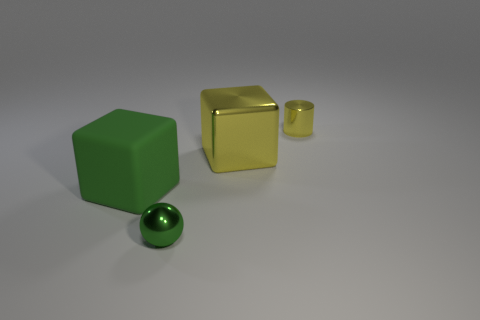Are there the same number of green objects that are to the left of the small green ball and tiny yellow metal things?
Offer a very short reply. Yes. There is a metal thing that is the same size as the ball; what is its shape?
Give a very brief answer. Cylinder. What number of other objects are there of the same shape as the green rubber thing?
Your answer should be very brief. 1. There is a yellow cylinder; is it the same size as the block to the right of the small ball?
Ensure brevity in your answer.  No. What number of objects are small objects that are in front of the large matte thing or tiny green balls?
Your answer should be compact. 1. What is the shape of the small thing in front of the yellow cube?
Offer a very short reply. Sphere. Is the number of tiny green metal spheres that are on the left side of the rubber object the same as the number of big yellow metallic objects that are in front of the tiny metal ball?
Your answer should be compact. Yes. The thing that is both behind the green block and in front of the tiny cylinder is what color?
Your answer should be compact. Yellow. There is a tiny thing that is in front of the yellow thing that is on the right side of the shiny cube; what is its material?
Give a very brief answer. Metal. Is the green shiny ball the same size as the metal cylinder?
Provide a short and direct response. Yes. 